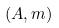Convert formula to latex. <formula><loc_0><loc_0><loc_500><loc_500>( A , m )</formula> 